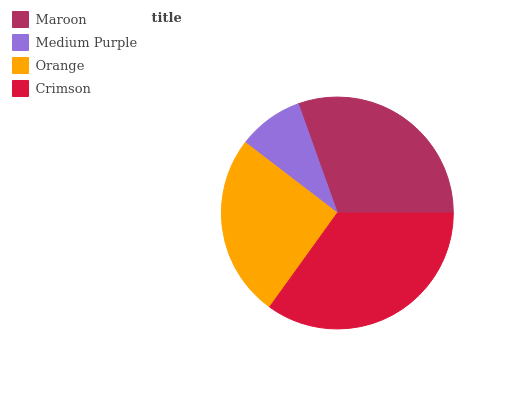Is Medium Purple the minimum?
Answer yes or no. Yes. Is Crimson the maximum?
Answer yes or no. Yes. Is Orange the minimum?
Answer yes or no. No. Is Orange the maximum?
Answer yes or no. No. Is Orange greater than Medium Purple?
Answer yes or no. Yes. Is Medium Purple less than Orange?
Answer yes or no. Yes. Is Medium Purple greater than Orange?
Answer yes or no. No. Is Orange less than Medium Purple?
Answer yes or no. No. Is Maroon the high median?
Answer yes or no. Yes. Is Orange the low median?
Answer yes or no. Yes. Is Orange the high median?
Answer yes or no. No. Is Medium Purple the low median?
Answer yes or no. No. 